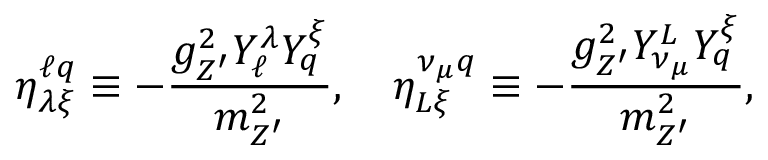<formula> <loc_0><loc_0><loc_500><loc_500>\eta _ { \lambda \xi } ^ { \ell q } \equiv - \frac { g _ { Z ^ { \prime } } ^ { 2 } Y _ { \ell } ^ { \lambda } Y _ { q } ^ { \xi } } { m _ { Z ^ { \prime } } ^ { 2 } } , \quad \eta _ { L \xi } ^ { \nu _ { \mu } q } \equiv - \frac { g _ { Z ^ { \prime } } ^ { 2 } Y _ { \nu _ { \mu } } ^ { L } Y _ { q } ^ { \xi } } { m _ { Z ^ { \prime } } ^ { 2 } } ,</formula> 